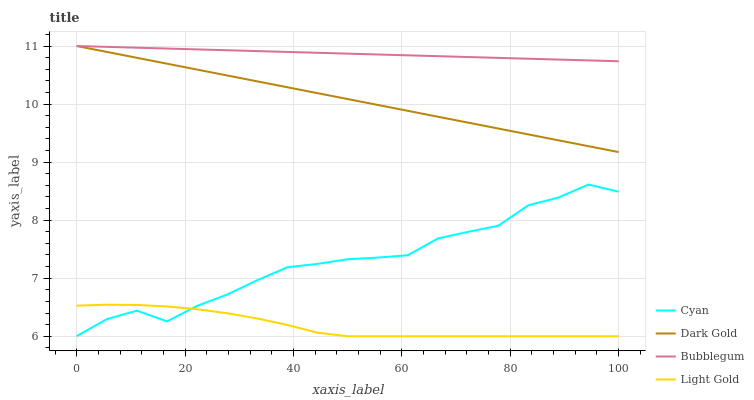Does Light Gold have the minimum area under the curve?
Answer yes or no. Yes. Does Bubblegum have the maximum area under the curve?
Answer yes or no. Yes. Does Bubblegum have the minimum area under the curve?
Answer yes or no. No. Does Light Gold have the maximum area under the curve?
Answer yes or no. No. Is Bubblegum the smoothest?
Answer yes or no. Yes. Is Cyan the roughest?
Answer yes or no. Yes. Is Light Gold the smoothest?
Answer yes or no. No. Is Light Gold the roughest?
Answer yes or no. No. Does Light Gold have the lowest value?
Answer yes or no. Yes. Does Bubblegum have the lowest value?
Answer yes or no. No. Does Dark Gold have the highest value?
Answer yes or no. Yes. Does Light Gold have the highest value?
Answer yes or no. No. Is Cyan less than Bubblegum?
Answer yes or no. Yes. Is Bubblegum greater than Cyan?
Answer yes or no. Yes. Does Light Gold intersect Cyan?
Answer yes or no. Yes. Is Light Gold less than Cyan?
Answer yes or no. No. Is Light Gold greater than Cyan?
Answer yes or no. No. Does Cyan intersect Bubblegum?
Answer yes or no. No. 